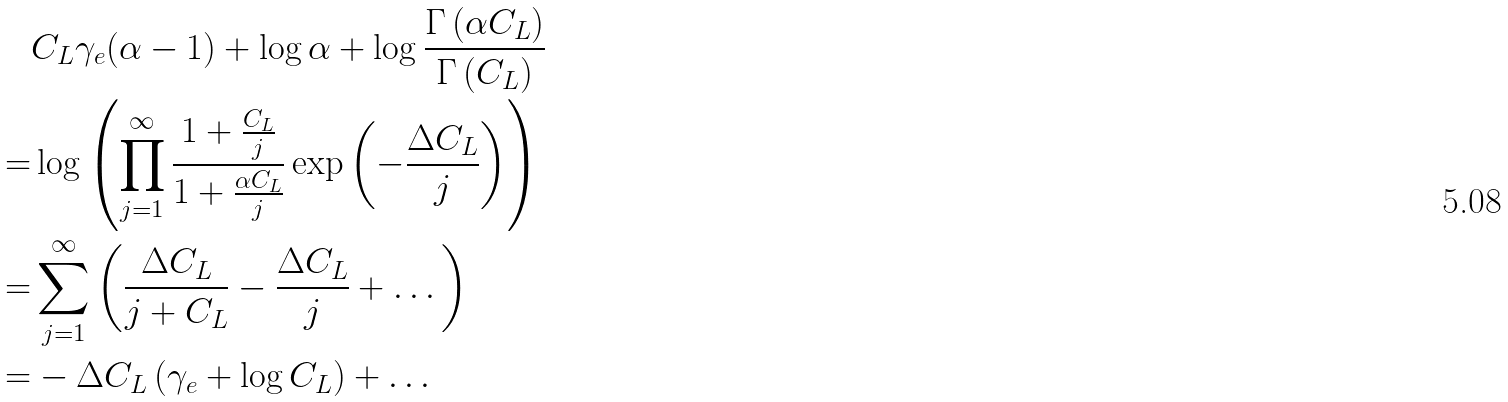Convert formula to latex. <formula><loc_0><loc_0><loc_500><loc_500>& C _ { L } \gamma _ { e } ( \alpha - 1 ) + \log \alpha + \log \frac { \Gamma \left ( \alpha C _ { L } \right ) } { \Gamma \left ( C _ { L } \right ) } \\ = & \log \left ( \prod _ { j = 1 } ^ { \infty } \frac { 1 + \frac { C _ { L } } { j } } { 1 + \frac { \alpha C _ { L } } { j } } \exp \left ( - \frac { \Delta C _ { L } } { j } \right ) \right ) \\ = & \sum _ { j = 1 } ^ { \infty } \left ( \frac { \Delta C _ { L } } { j + C _ { L } } - \frac { \Delta C _ { L } } { j } + \dots \right ) \\ = & - \Delta C _ { L } \left ( \gamma _ { e } + \log C _ { L } \right ) + \dots</formula> 